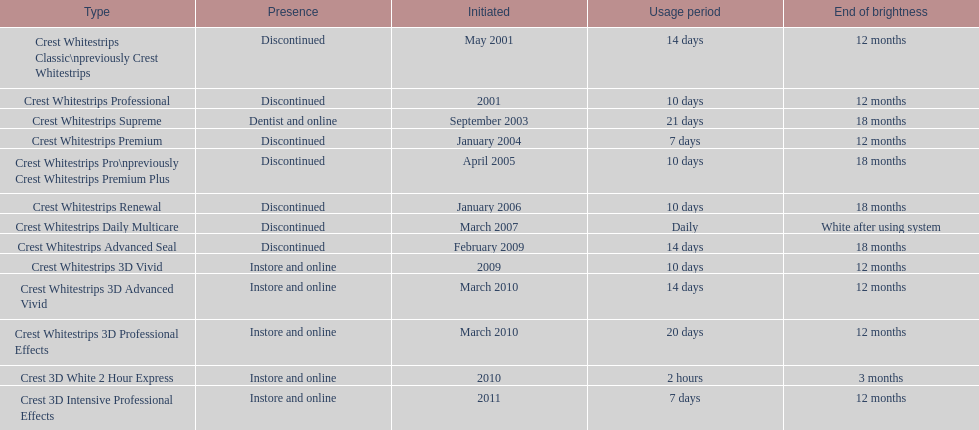Which discontinued product was introduced the same year as crest whitestrips 3d vivid? Crest Whitestrips Advanced Seal. 